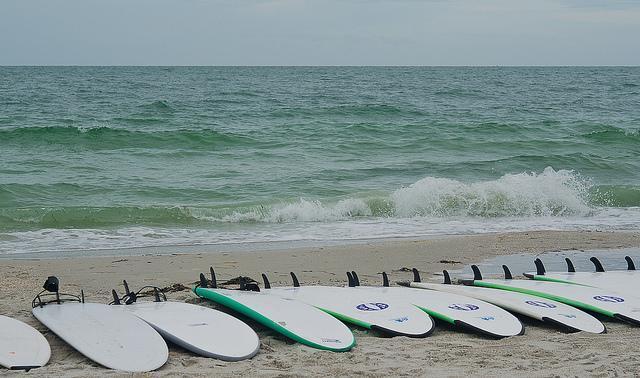How many people are in the water?
Give a very brief answer. 0. How many surfboards are there?
Give a very brief answer. 8. How many people are wearing pink helmets?
Give a very brief answer. 0. 